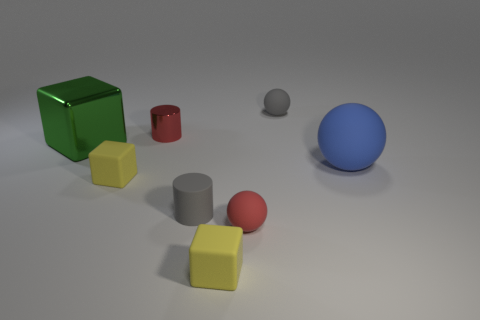What might be the purpose of these objects if they were part of a teaching tool? If these objects were part of a teaching tool, they could be used to educate on geometry and shapes, comparing sizes, understanding colors, and differentiating materials and textures in a tactile and visual manner. Can you think of a specific lesson that could be taught using these objects? A specific lesson could involve grouping the objects by shape or color, and then by material—rubber versus metal—to teach sorting and categorizing skills, as well as to discuss the properties of different materials and why they might be used for various applications. 